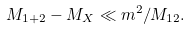<formula> <loc_0><loc_0><loc_500><loc_500>M _ { 1 + 2 } - M _ { X } \ll m ^ { 2 } / M _ { 1 2 } .</formula> 